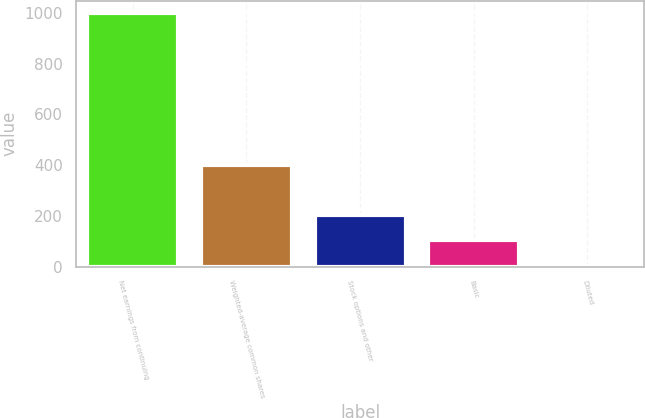Convert chart. <chart><loc_0><loc_0><loc_500><loc_500><bar_chart><fcel>Net earnings from continuing<fcel>Weighted-average common shares<fcel>Stock options and other<fcel>Basic<fcel>Diluted<nl><fcel>999<fcel>401.54<fcel>202.4<fcel>102.83<fcel>3.26<nl></chart> 